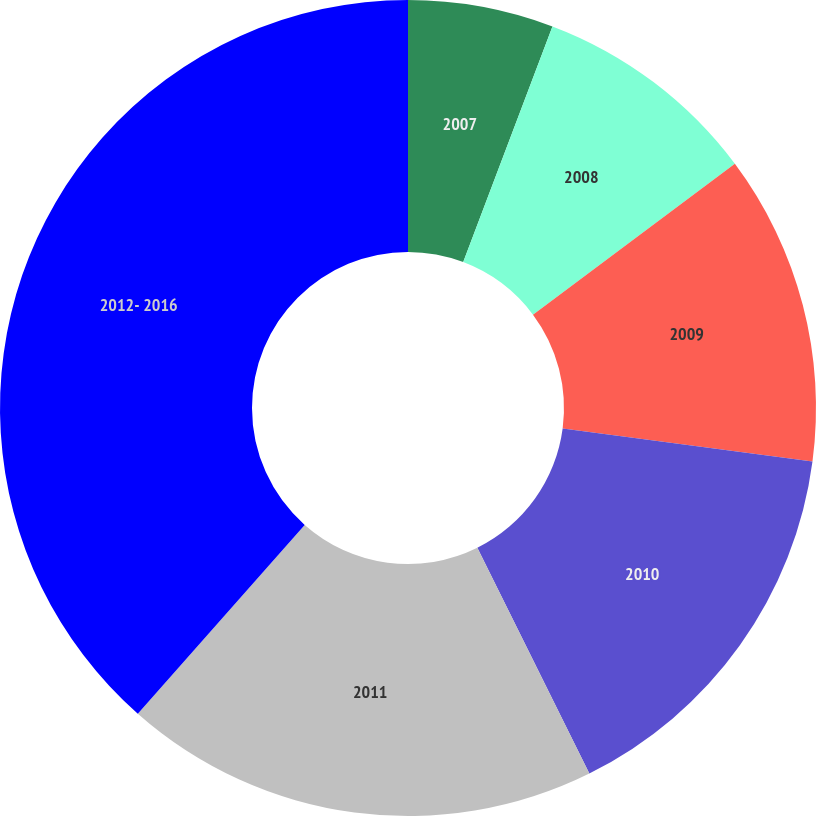Convert chart. <chart><loc_0><loc_0><loc_500><loc_500><pie_chart><fcel>2007<fcel>2008<fcel>2009<fcel>2010<fcel>2011<fcel>2012- 2016<nl><fcel>5.76%<fcel>9.03%<fcel>12.3%<fcel>15.58%<fcel>18.85%<fcel>38.48%<nl></chart> 